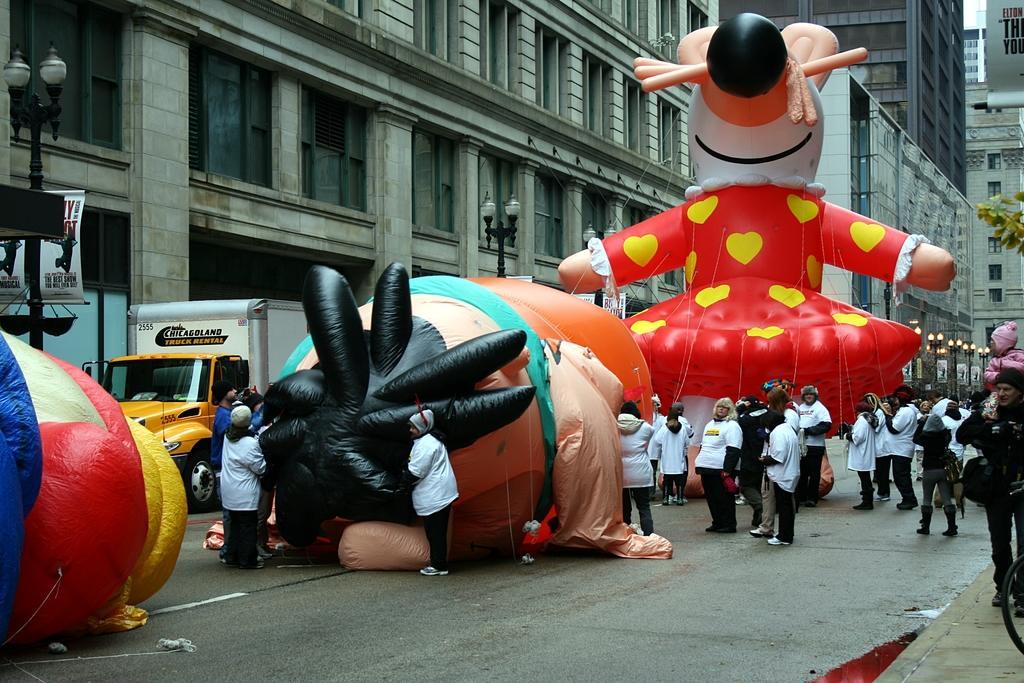Please provide a concise description of this image. In this image we can see a group of people standing on the road. In the center of the image we can see a group of balloons with ropes and a vehicle is placed on the ground. On the right side of the image we can see a person carrying a baby on his shoulders. In the background, we can see some light poles, a banner with some text, a group of buildings with windows and the sky. 